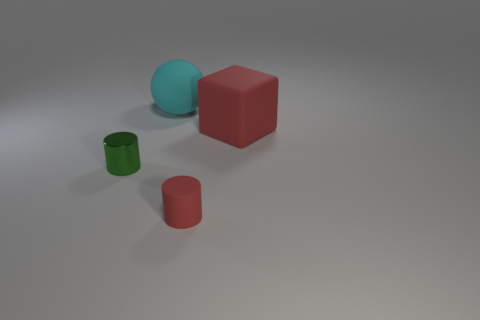Add 2 metallic cylinders. How many objects exist? 6 Subtract all blocks. How many objects are left? 3 Add 2 big cyan matte balls. How many big cyan matte balls are left? 3 Add 1 large cyan rubber spheres. How many large cyan rubber spheres exist? 2 Subtract 0 yellow blocks. How many objects are left? 4 Subtract all small red matte things. Subtract all cyan objects. How many objects are left? 2 